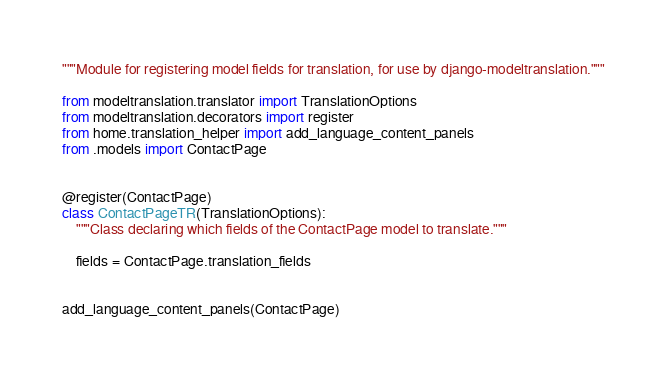<code> <loc_0><loc_0><loc_500><loc_500><_Python_>"""Module for registering model fields for translation, for use by django-modeltranslation."""

from modeltranslation.translator import TranslationOptions
from modeltranslation.decorators import register
from home.translation_helper import add_language_content_panels
from .models import ContactPage


@register(ContactPage)
class ContactPageTR(TranslationOptions):
    """Class declaring which fields of the ContactPage model to translate."""

    fields = ContactPage.translation_fields


add_language_content_panels(ContactPage)
</code> 